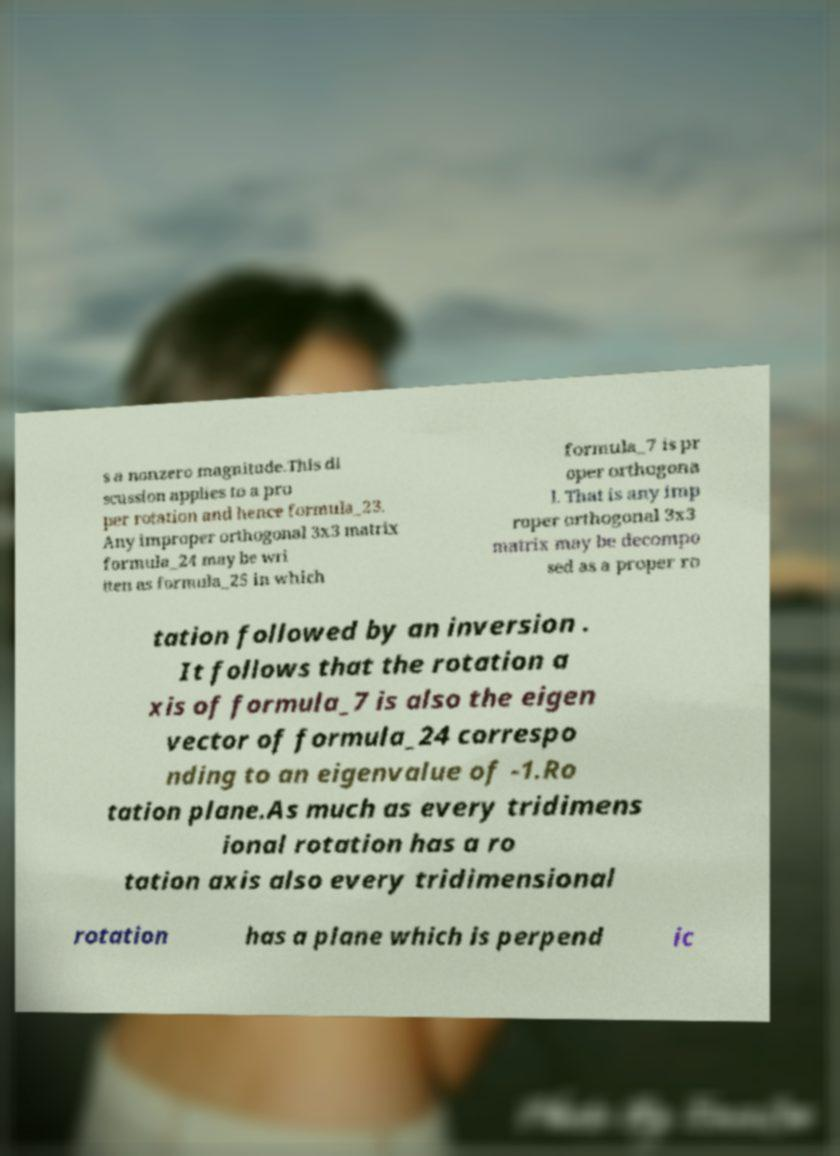Please identify and transcribe the text found in this image. s a nonzero magnitude.This di scussion applies to a pro per rotation and hence formula_23. Any improper orthogonal 3x3 matrix formula_24 may be wri tten as formula_25 in which formula_7 is pr oper orthogona l. That is any imp roper orthogonal 3x3 matrix may be decompo sed as a proper ro tation followed by an inversion . It follows that the rotation a xis of formula_7 is also the eigen vector of formula_24 correspo nding to an eigenvalue of -1.Ro tation plane.As much as every tridimens ional rotation has a ro tation axis also every tridimensional rotation has a plane which is perpend ic 